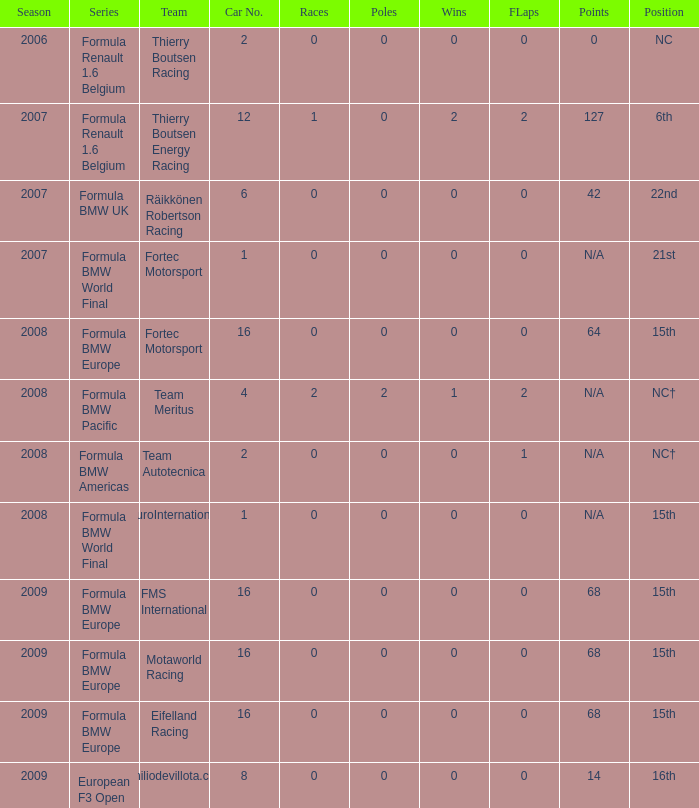Identify the scores for vehicle number N/A. 